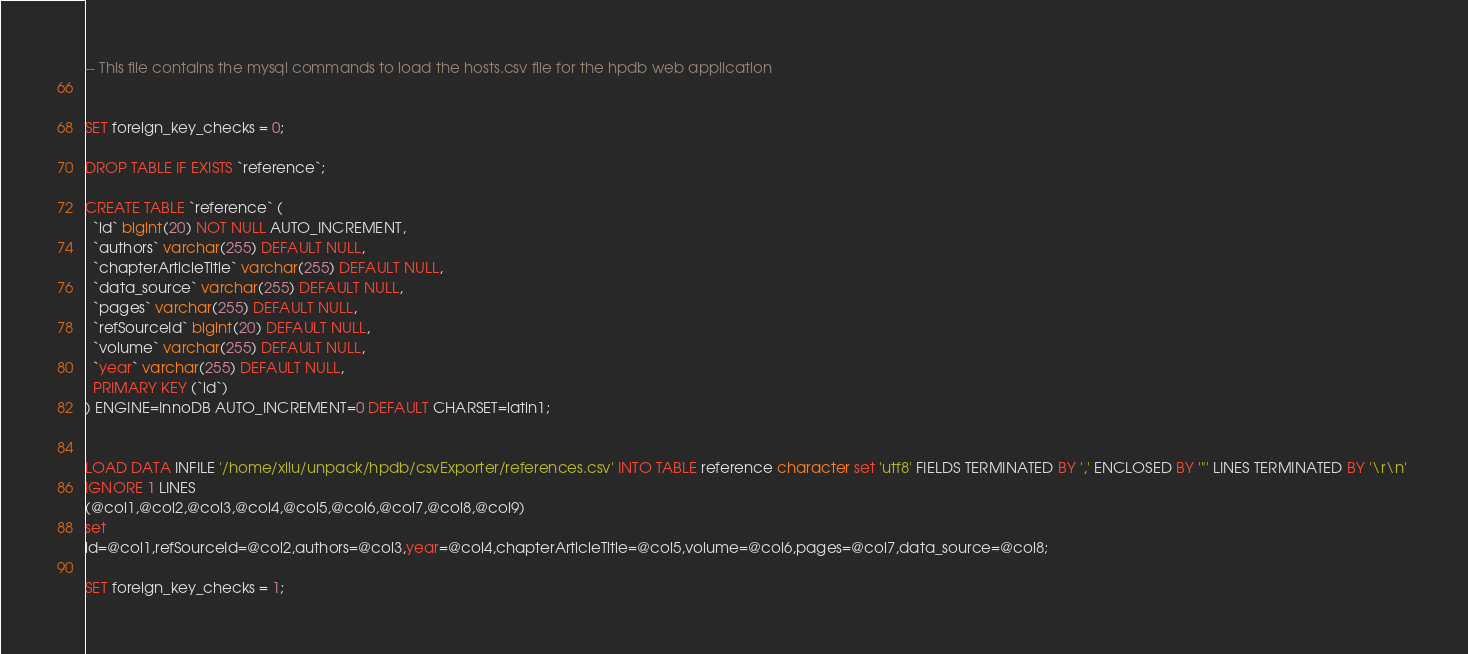<code> <loc_0><loc_0><loc_500><loc_500><_SQL_>-- This file contains the mysql commands to load the hosts.csv file for the hpdb web application


SET foreign_key_checks = 0;

DROP TABLE IF EXISTS `reference`;

CREATE TABLE `reference` (
  `id` bigint(20) NOT NULL AUTO_INCREMENT,
  `authors` varchar(255) DEFAULT NULL,
  `chapterArticleTitle` varchar(255) DEFAULT NULL,
  `data_source` varchar(255) DEFAULT NULL,
  `pages` varchar(255) DEFAULT NULL,
  `refSourceId` bigint(20) DEFAULT NULL,
  `volume` varchar(255) DEFAULT NULL,
  `year` varchar(255) DEFAULT NULL,
  PRIMARY KEY (`id`)
) ENGINE=InnoDB AUTO_INCREMENT=0 DEFAULT CHARSET=latin1;


LOAD DATA INFILE '/home/xilu/unpack/hpdb/csvExporter/references.csv' INTO TABLE reference character set 'utf8' FIELDS TERMINATED BY ',' ENCLOSED BY '"' LINES TERMINATED BY '\r\n' 
IGNORE 1 LINES 
(@col1,@col2,@col3,@col4,@col5,@col6,@col7,@col8,@col9) 
set 
id=@col1,refSourceId=@col2,authors=@col3,year=@col4,chapterArticleTitle=@col5,volume=@col6,pages=@col7,data_source=@col8;

SET foreign_key_checks = 1;


</code> 